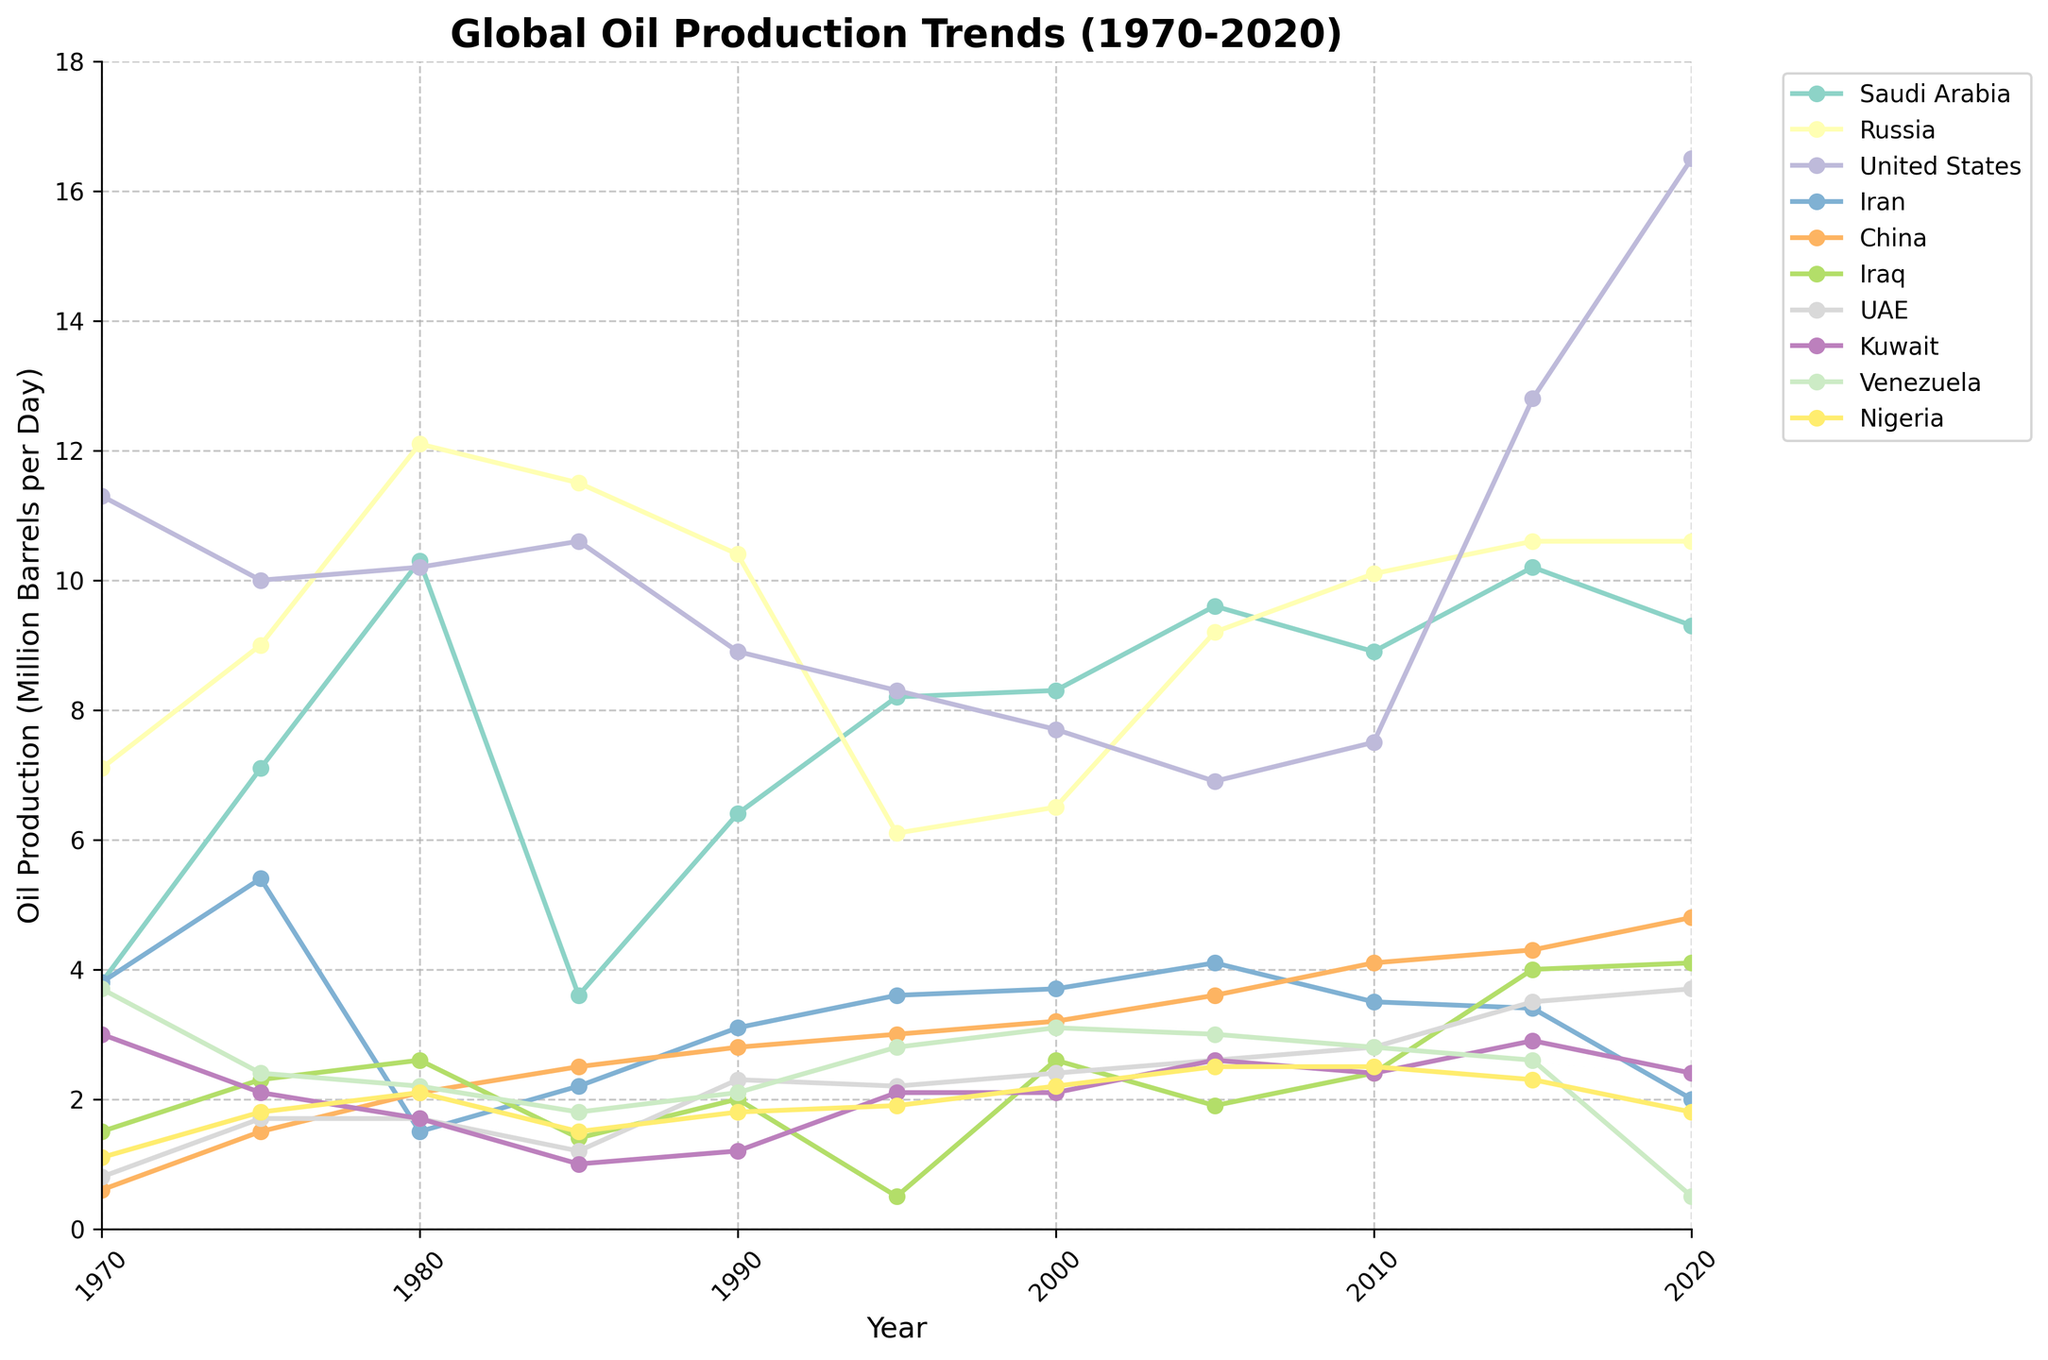What country had the highest oil production in 1980? By observing the line chart, locate the point in 1980 for each country and identify the highest one. The highest point of 12.1 million barrels per day belongs to Russia.
Answer: Russia Which two countries had nearly similar oil production around the year 2000? Looking at the year 2000 on the x-axis, observe which country lines are close to each other. Saudi Arabia and Russia had similar oil production values of 8.3 and 6.5 million barrels per day, respectively.
Answer: Saudi Arabia and Russia By how much did the oil production in the United States increase from 2010 to 2020? Identify the oil production values for the United States in 2010 and 2020. The values are 7.5 and 16.5 million barrels per day. Calculate the increase: 16.5 - 7.5 = 9
Answer: 9 million barrels per day Which year did Iran's oil production peak between 1970 and 2020 and what was the value? Locate Iran's line and find the highest point on that line between 1970 and 2020. The peak production was in 1975 with a value of 5.4 million barrels per day.
Answer: 1975, 5.4 million barrels per day Did any country have an oil production drop between 1975 and 1980? If yes, which one(s)? Compare the oil production values for 1975 and 1980 for each country to see if any had a decrease. The United States and Iran showed a decrease.
Answer: United States and Iran In terms of visual attributes, which country's oil production trend line uses a green color? Identify the green-colored line on the chart looking at the legend for matching the country name.
Answer: China Between 1990 and 2000, what was the average oil production of Kuwait? Find the values for Kuwait in 1990 and 2000 which are 1.2 and 2.1. Calculating the average: (1.2 + 2.1) / 2 = 1.65
Answer: 1.65 million barrels per day Comparing 1970 and 2020, which country had the greatest increase in oil production? Identify the production values for each country for 1970 and 2020 and calculate the difference. The United States had the greatest increase: 16.5 - 11.3 = 5.2
Answer: United States What is the total oil production of Nigeria and UAE in 2020? Locate the values for Nigeria (1.8) and UAE (3.7) in 2020 and add them together: 1.8 + 3.7 = 5.5
Answer: 5.5 million barrels per day 